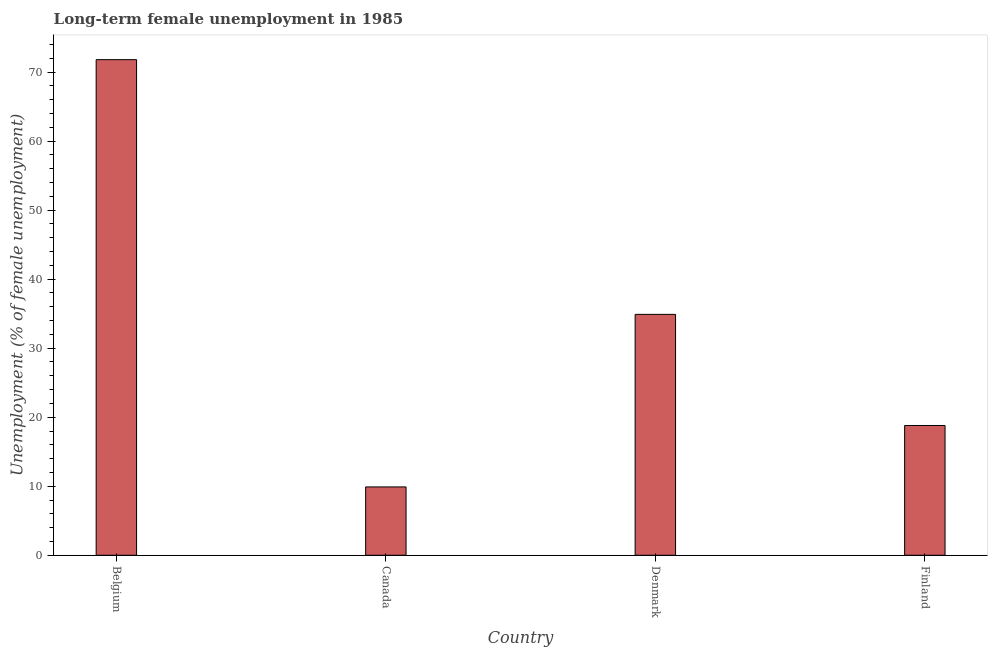Does the graph contain grids?
Offer a terse response. No. What is the title of the graph?
Provide a short and direct response. Long-term female unemployment in 1985. What is the label or title of the X-axis?
Provide a short and direct response. Country. What is the label or title of the Y-axis?
Provide a short and direct response. Unemployment (% of female unemployment). What is the long-term female unemployment in Belgium?
Your answer should be compact. 71.8. Across all countries, what is the maximum long-term female unemployment?
Provide a short and direct response. 71.8. Across all countries, what is the minimum long-term female unemployment?
Offer a very short reply. 9.9. In which country was the long-term female unemployment minimum?
Your answer should be very brief. Canada. What is the sum of the long-term female unemployment?
Keep it short and to the point. 135.4. What is the difference between the long-term female unemployment in Belgium and Denmark?
Your answer should be very brief. 36.9. What is the average long-term female unemployment per country?
Give a very brief answer. 33.85. What is the median long-term female unemployment?
Give a very brief answer. 26.85. In how many countries, is the long-term female unemployment greater than 42 %?
Your answer should be compact. 1. What is the ratio of the long-term female unemployment in Belgium to that in Denmark?
Your response must be concise. 2.06. Is the difference between the long-term female unemployment in Canada and Denmark greater than the difference between any two countries?
Ensure brevity in your answer.  No. What is the difference between the highest and the second highest long-term female unemployment?
Your response must be concise. 36.9. Is the sum of the long-term female unemployment in Denmark and Finland greater than the maximum long-term female unemployment across all countries?
Your answer should be compact. No. What is the difference between the highest and the lowest long-term female unemployment?
Your response must be concise. 61.9. In how many countries, is the long-term female unemployment greater than the average long-term female unemployment taken over all countries?
Make the answer very short. 2. What is the difference between two consecutive major ticks on the Y-axis?
Make the answer very short. 10. What is the Unemployment (% of female unemployment) of Belgium?
Your answer should be compact. 71.8. What is the Unemployment (% of female unemployment) in Canada?
Your answer should be compact. 9.9. What is the Unemployment (% of female unemployment) of Denmark?
Make the answer very short. 34.9. What is the Unemployment (% of female unemployment) of Finland?
Make the answer very short. 18.8. What is the difference between the Unemployment (% of female unemployment) in Belgium and Canada?
Offer a terse response. 61.9. What is the difference between the Unemployment (% of female unemployment) in Belgium and Denmark?
Your response must be concise. 36.9. What is the difference between the Unemployment (% of female unemployment) in Belgium and Finland?
Provide a short and direct response. 53. What is the difference between the Unemployment (% of female unemployment) in Canada and Denmark?
Offer a terse response. -25. What is the ratio of the Unemployment (% of female unemployment) in Belgium to that in Canada?
Keep it short and to the point. 7.25. What is the ratio of the Unemployment (% of female unemployment) in Belgium to that in Denmark?
Provide a short and direct response. 2.06. What is the ratio of the Unemployment (% of female unemployment) in Belgium to that in Finland?
Your answer should be compact. 3.82. What is the ratio of the Unemployment (% of female unemployment) in Canada to that in Denmark?
Offer a terse response. 0.28. What is the ratio of the Unemployment (% of female unemployment) in Canada to that in Finland?
Offer a very short reply. 0.53. What is the ratio of the Unemployment (% of female unemployment) in Denmark to that in Finland?
Give a very brief answer. 1.86. 